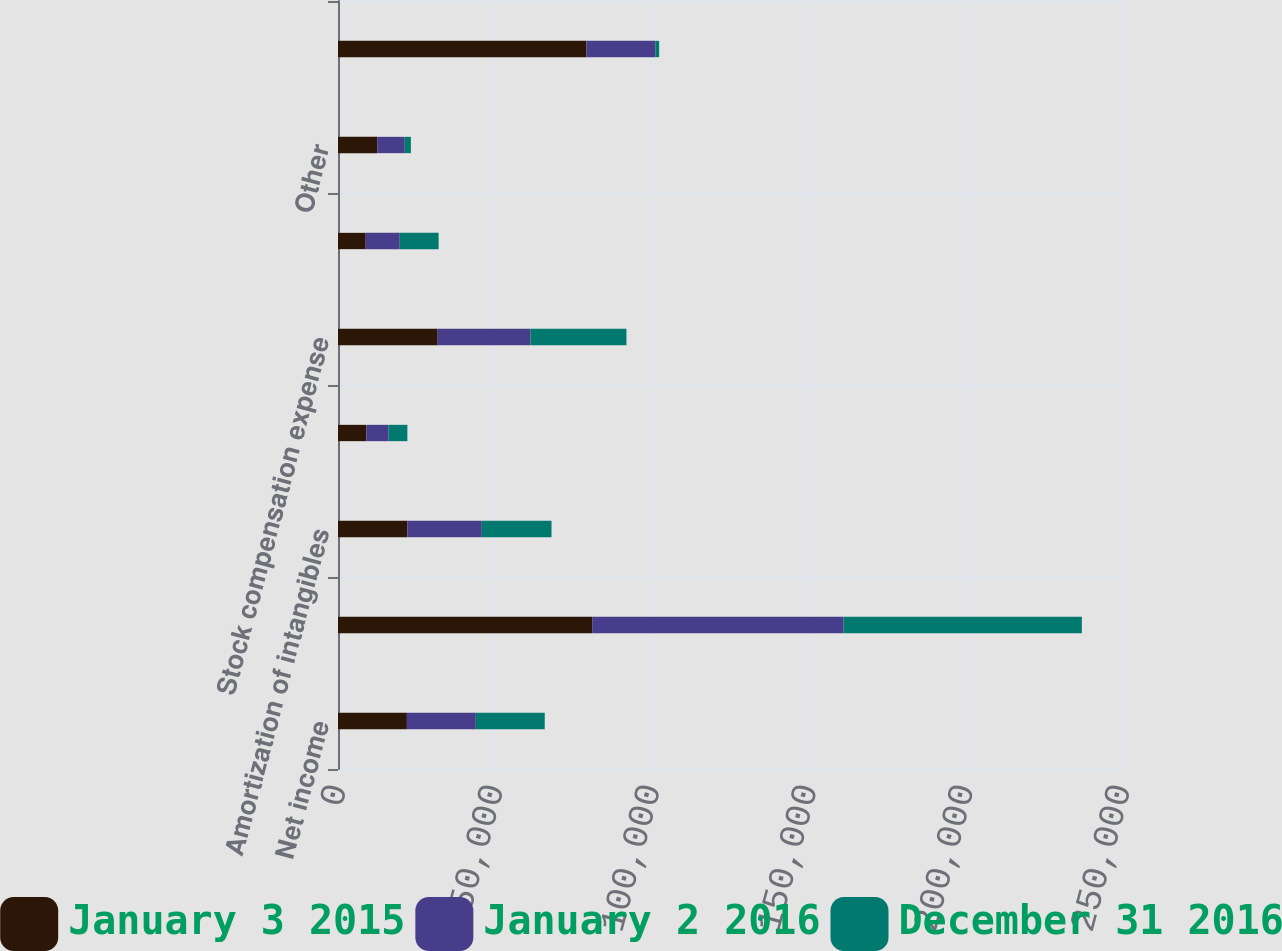Convert chart. <chart><loc_0><loc_0><loc_500><loc_500><stacked_bar_chart><ecel><fcel>Net income<fcel>Depreciation<fcel>Amortization of intangibles<fcel>Amortization of debt issuance<fcel>Stock compensation expense<fcel>Deferred taxes<fcel>Other<fcel>Accounts receivable<nl><fcel>January 3 2015<fcel>21974<fcel>81057<fcel>22118<fcel>9034<fcel>31780<fcel>8836<fcel>12587<fcel>79211<nl><fcel>January 2 2016<fcel>21974<fcel>80166<fcel>23737<fcel>7077<fcel>29618<fcel>10850<fcel>8696<fcel>21974<nl><fcel>December 31 2016<fcel>21974<fcel>75977<fcel>22225<fcel>6011<fcel>30587<fcel>12401<fcel>1962<fcel>1228<nl></chart> 